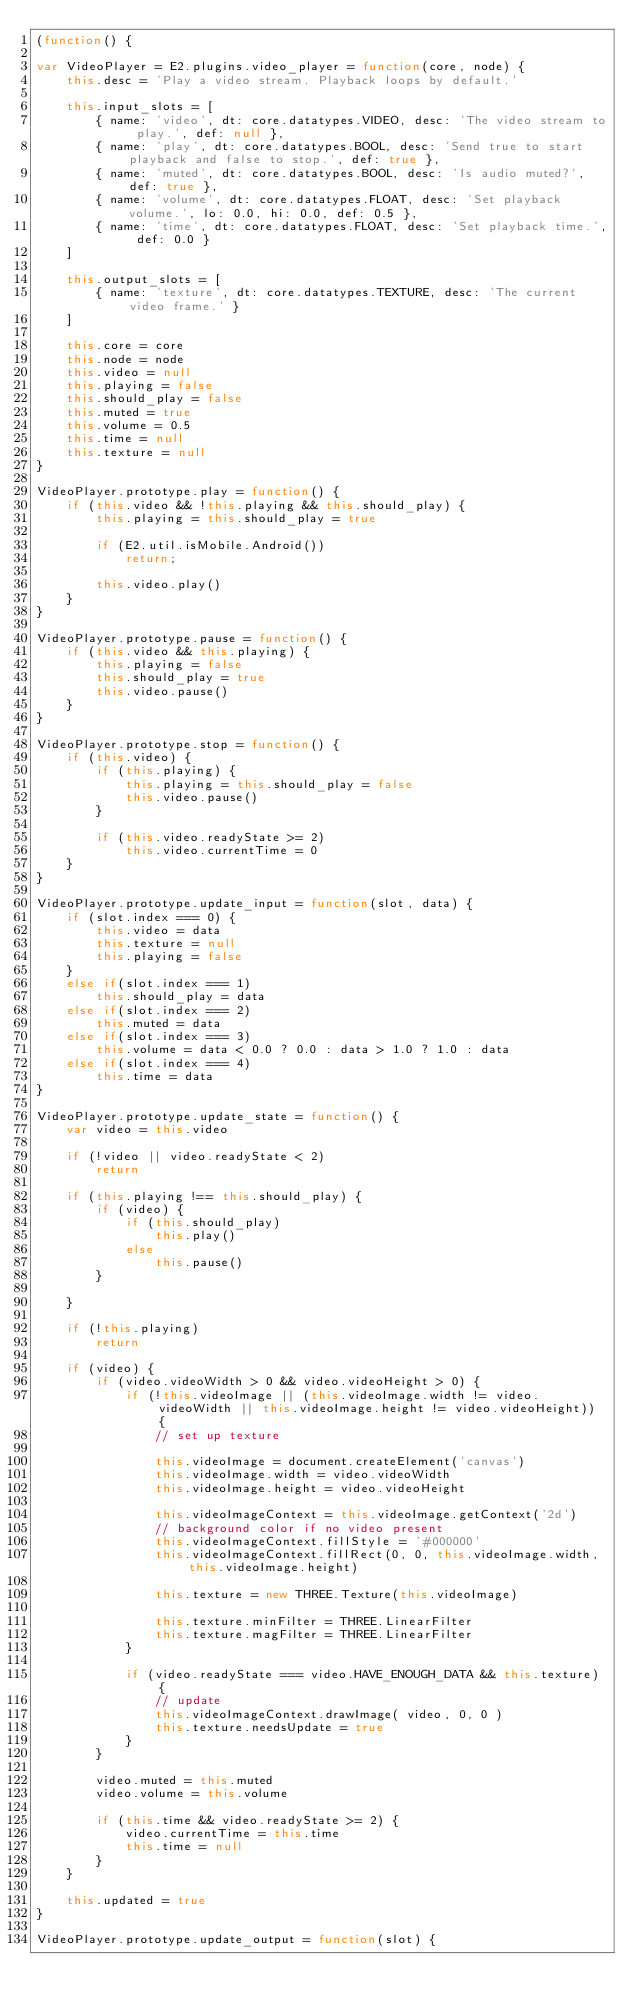Convert code to text. <code><loc_0><loc_0><loc_500><loc_500><_JavaScript_>(function() {

var VideoPlayer = E2.plugins.video_player = function(core, node) {
	this.desc = 'Play a video stream. Playback loops by default.'
	
	this.input_slots = [ 
		{ name: 'video', dt: core.datatypes.VIDEO, desc: 'The video stream to play.', def: null },
		{ name: 'play', dt: core.datatypes.BOOL, desc: 'Send true to start playback and false to stop.', def: true },
		{ name: 'muted', dt: core.datatypes.BOOL, desc: 'Is audio muted?', def: true },
		{ name: 'volume', dt: core.datatypes.FLOAT, desc: 'Set playback volume.', lo: 0.0, hi: 0.0, def: 0.5 },
		{ name: 'time', dt: core.datatypes.FLOAT, desc: 'Set playback time.', def: 0.0 }
	]
	
	this.output_slots = [
		{ name: 'texture', dt: core.datatypes.TEXTURE, desc: 'The current video frame.' }
	]
	
	this.core = core
	this.node = node
	this.video = null
	this.playing = false
	this.should_play = false
	this.muted = true
	this.volume = 0.5
	this.time = null
	this.texture = null
}

VideoPlayer.prototype.play = function() {
	if (this.video && !this.playing && this.should_play) {
		this.playing = this.should_play = true
		
		if (E2.util.isMobile.Android())
			return;
		
		this.video.play()
	}
}

VideoPlayer.prototype.pause = function() {
	if (this.video && this.playing) {
		this.playing = false
		this.should_play = true
		this.video.pause()
	}
}

VideoPlayer.prototype.stop = function() {
	if (this.video) {
		if (this.playing) {
			this.playing = this.should_play = false
			this.video.pause()
		}
		
		if (this.video.readyState >= 2)
			this.video.currentTime = 0
	}
}

VideoPlayer.prototype.update_input = function(slot, data) {
	if (slot.index === 0) {
		this.video = data
		this.texture = null
		this.playing = false
	}
	else if(slot.index === 1)
		this.should_play = data
	else if(slot.index === 2)
		this.muted = data
	else if(slot.index === 3)
		this.volume = data < 0.0 ? 0.0 : data > 1.0 ? 1.0 : data
	else if(slot.index === 4)
		this.time = data
}

VideoPlayer.prototype.update_state = function() {
	var video = this.video
	
	if (!video || video.readyState < 2)
		return
	
	if (this.playing !== this.should_play) {
		if (video) {
			if (this.should_play)
				this.play()
			else
				this.pause()
		}
		
	}
	
	if (!this.playing)
		return

	if (video) {
		if (video.videoWidth > 0 && video.videoHeight > 0) {
			if (!this.videoImage || (this.videoImage.width != video.videoWidth || this.videoImage.height != video.videoHeight)) {
				// set up texture

				this.videoImage = document.createElement('canvas')
				this.videoImage.width = video.videoWidth
				this.videoImage.height = video.videoHeight

				this.videoImageContext = this.videoImage.getContext('2d')
				// background color if no video present
				this.videoImageContext.fillStyle = '#000000'
				this.videoImageContext.fillRect(0, 0, this.videoImage.width, this.videoImage.height)

				this.texture = new THREE.Texture(this.videoImage)

				this.texture.minFilter = THREE.LinearFilter
				this.texture.magFilter = THREE.LinearFilter
			}
			
			if (video.readyState === video.HAVE_ENOUGH_DATA && this.texture) {
				// update
				this.videoImageContext.drawImage( video, 0, 0 )
				this.texture.needsUpdate = true
			}
		}
		
		video.muted = this.muted
		video.volume = this.volume
		
		if (this.time && video.readyState >= 2) {
			video.currentTime = this.time
			this.time = null
		}
	}

	this.updated = true
}

VideoPlayer.prototype.update_output = function(slot) {</code> 